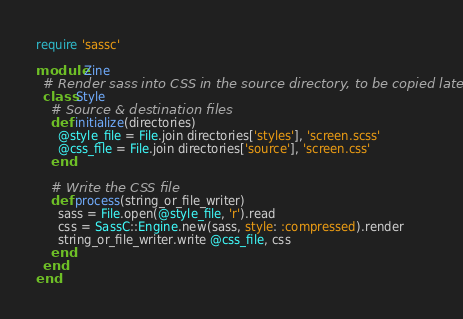<code> <loc_0><loc_0><loc_500><loc_500><_Ruby_>require 'sassc'

module Zine
  # Render sass into CSS in the source directory, to be copied later
  class Style
    # Source & destination files
    def initialize(directories)
      @style_file = File.join directories['styles'], 'screen.scss'
      @css_file = File.join directories['source'], 'screen.css'
    end

    # Write the CSS file
    def process(string_or_file_writer)
      sass = File.open(@style_file, 'r').read
      css = SassC::Engine.new(sass, style: :compressed).render
      string_or_file_writer.write @css_file, css
    end
  end
end
</code> 